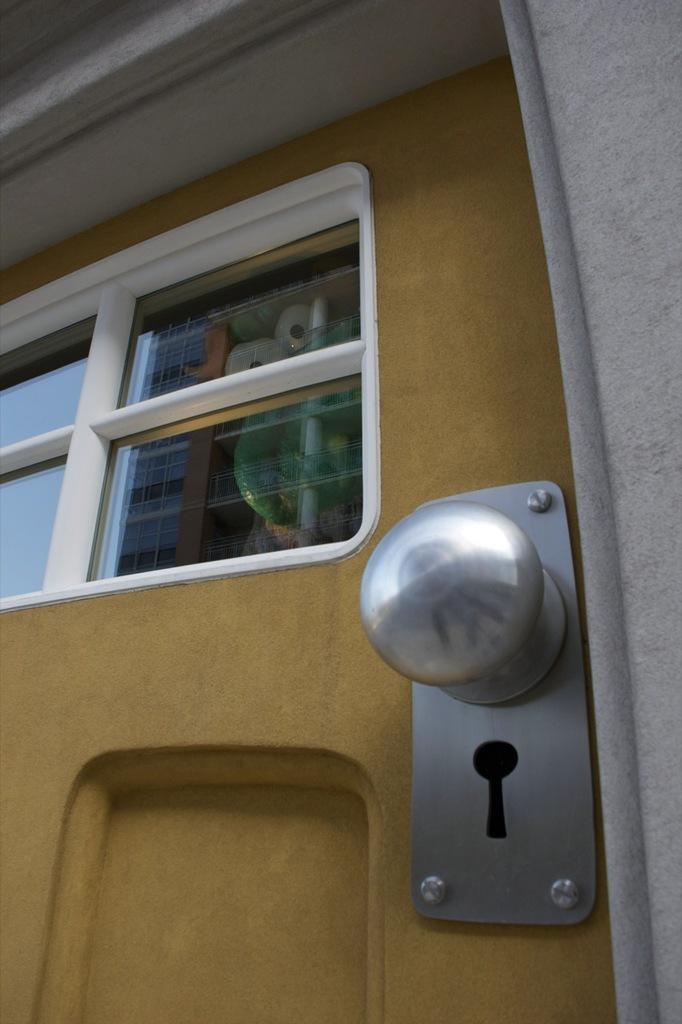What type of structure is present in the image? There is a door in the image. What feature can be seen on the door? There is a window on the door. How can the door be opened or closed? There is a door handle on the door. What type of beef is being cooked in the image? There is no beef or cooking activity present in the image; it only features a door with a window and door handle. 